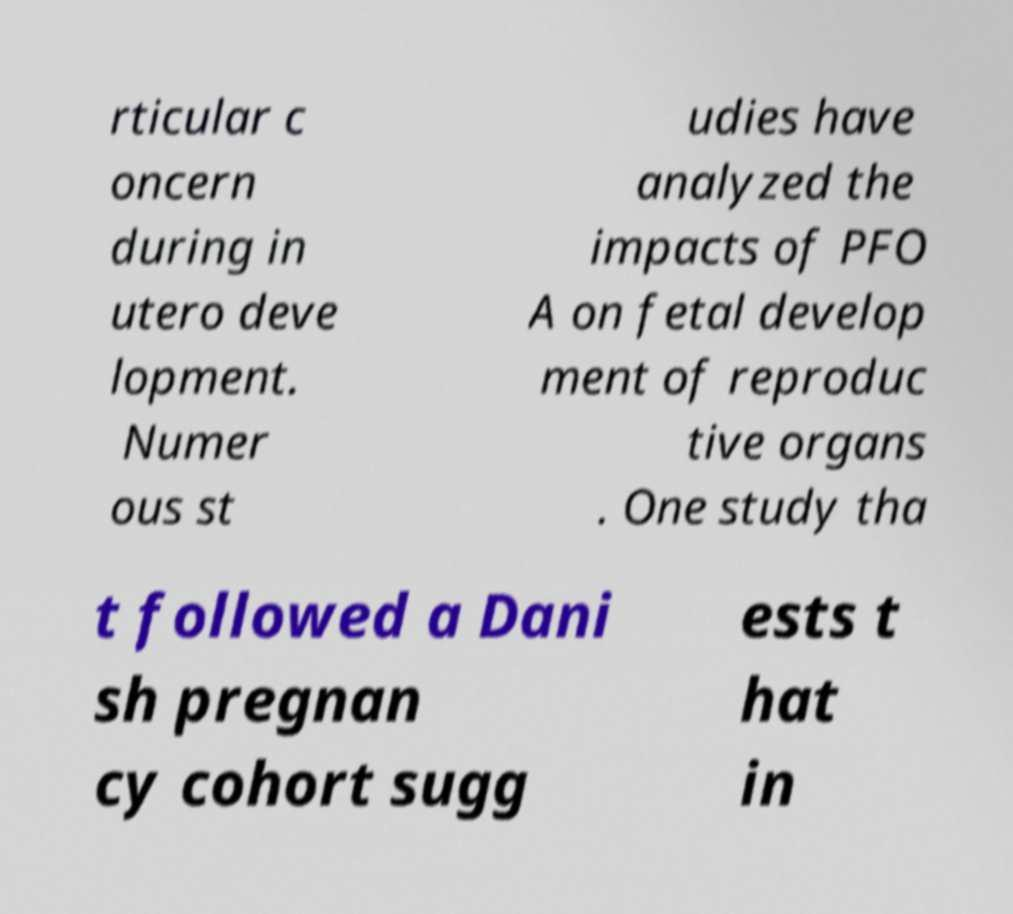Please read and relay the text visible in this image. What does it say? rticular c oncern during in utero deve lopment. Numer ous st udies have analyzed the impacts of PFO A on fetal develop ment of reproduc tive organs . One study tha t followed a Dani sh pregnan cy cohort sugg ests t hat in 